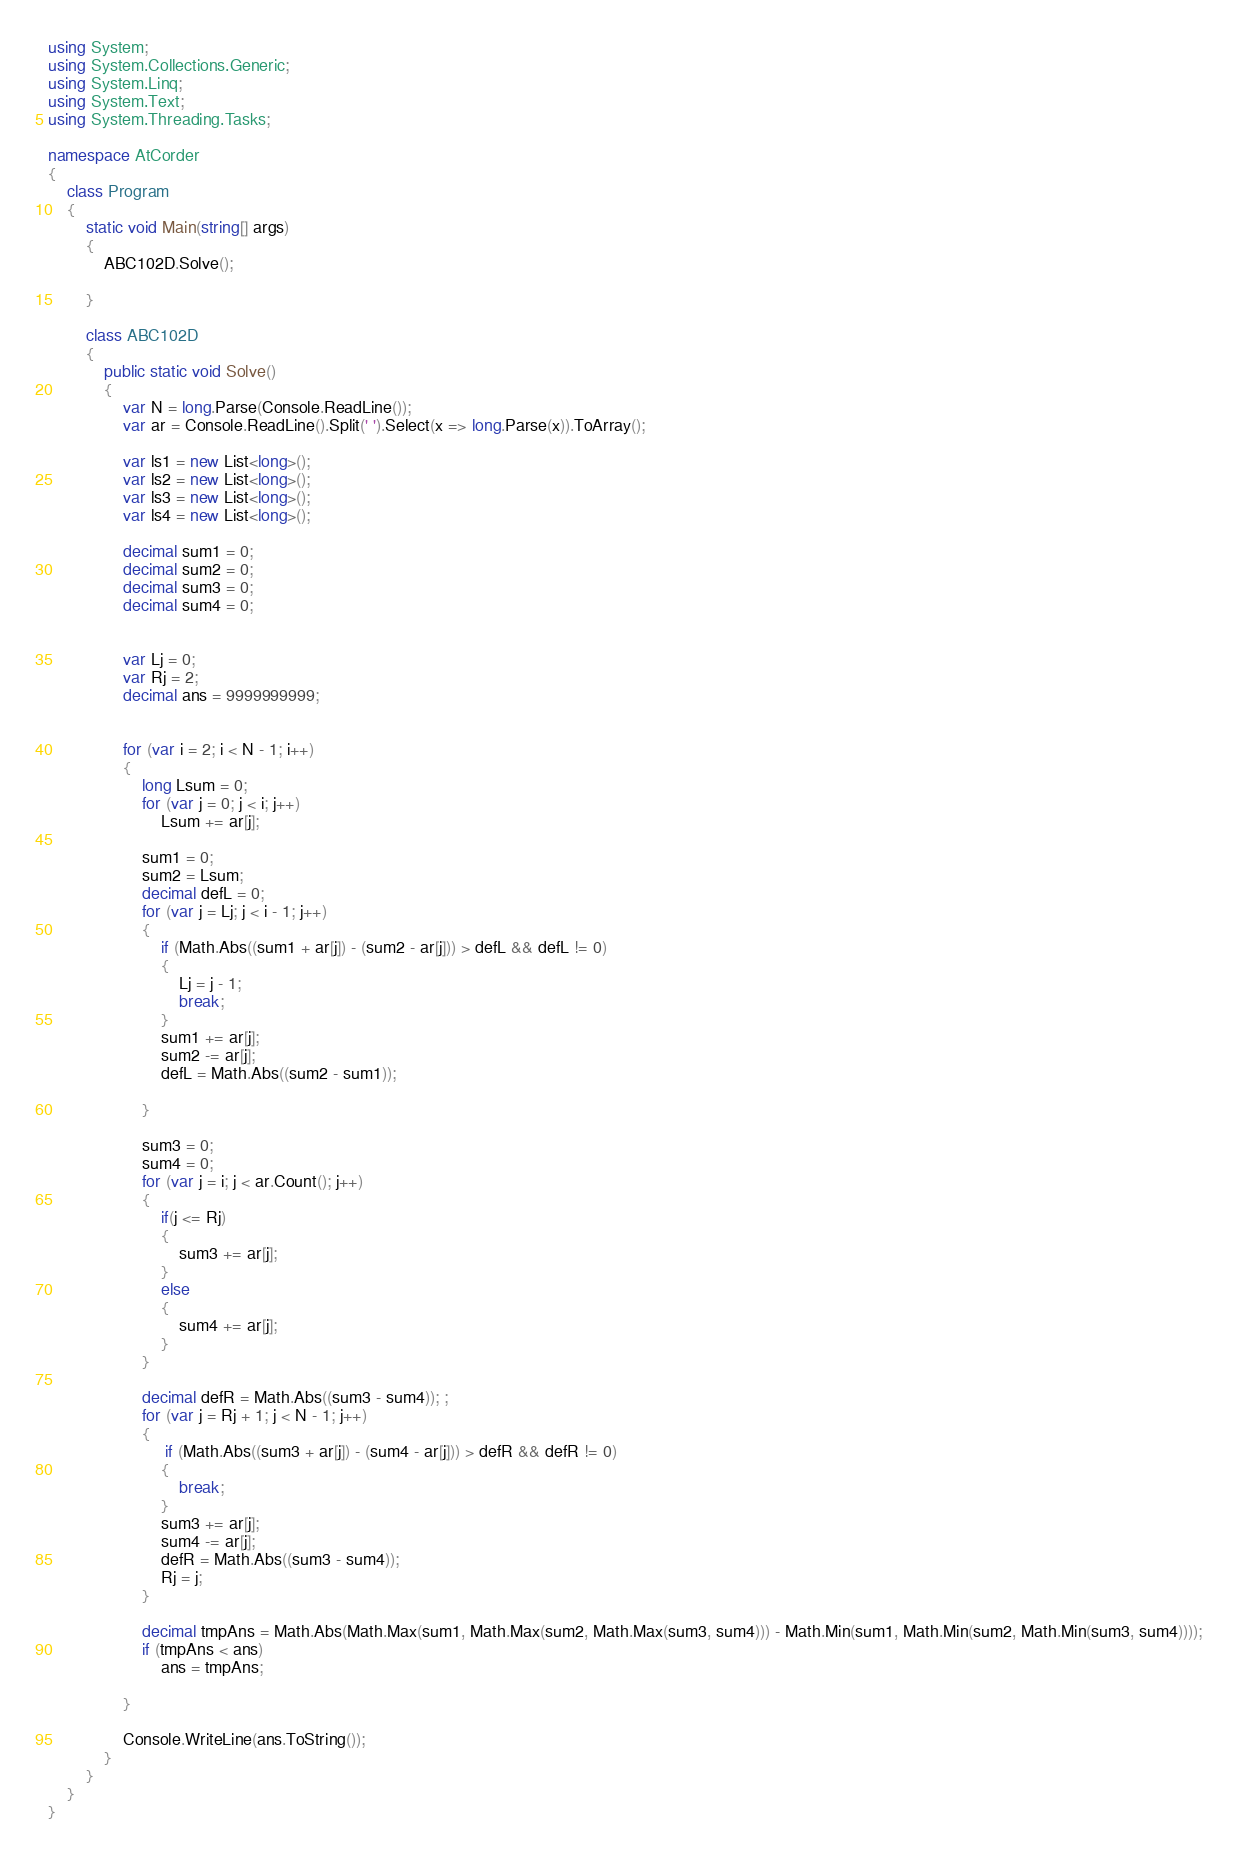<code> <loc_0><loc_0><loc_500><loc_500><_C#_>using System;
using System.Collections.Generic;
using System.Linq;
using System.Text;
using System.Threading.Tasks;

namespace AtCorder
{
    class Program
    {
        static void Main(string[] args)
        {
            ABC102D.Solve();

        }

        class ABC102D
        {
            public static void Solve()
            {
                var N = long.Parse(Console.ReadLine());
                var ar = Console.ReadLine().Split(' ').Select(x => long.Parse(x)).ToArray();

                var ls1 = new List<long>();
                var ls2 = new List<long>();
                var ls3 = new List<long>();
                var ls4 = new List<long>();

                decimal sum1 = 0;
                decimal sum2 = 0;
                decimal sum3 = 0;
                decimal sum4 = 0;


                var Lj = 0;
                var Rj = 2;
                decimal ans = 9999999999;


                for (var i = 2; i < N - 1; i++)
                {
                    long Lsum = 0;
                    for (var j = 0; j < i; j++)
                        Lsum += ar[j];

                    sum1 = 0;
                    sum2 = Lsum;
                    decimal defL = 0;
                    for (var j = Lj; j < i - 1; j++)
                    {
                        if (Math.Abs((sum1 + ar[j]) - (sum2 - ar[j])) > defL && defL != 0)
                        {
                            Lj = j - 1;
                            break;
                        }
                        sum1 += ar[j];
                        sum2 -= ar[j];
                        defL = Math.Abs((sum2 - sum1));

                    }

                    sum3 = 0;
                    sum4 = 0;
                    for (var j = i; j < ar.Count(); j++)
                    {
                        if(j <= Rj)
                        {
                            sum3 += ar[j];
                        }
                        else
                        {
                            sum4 += ar[j];
                        }
                    }

                    decimal defR = Math.Abs((sum3 - sum4)); ;
                    for (var j = Rj + 1; j < N - 1; j++)
                    {
                         if (Math.Abs((sum3 + ar[j]) - (sum4 - ar[j])) > defR && defR != 0)
                        {
                            break;
                        }
                        sum3 += ar[j];
                        sum4 -= ar[j];
                        defR = Math.Abs((sum3 - sum4));
                        Rj = j;
                    }

                    decimal tmpAns = Math.Abs(Math.Max(sum1, Math.Max(sum2, Math.Max(sum3, sum4))) - Math.Min(sum1, Math.Min(sum2, Math.Min(sum3, sum4))));
                    if (tmpAns < ans)
                        ans = tmpAns;

                }

                Console.WriteLine(ans.ToString());
            }
        }
    }
}
</code> 